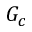Convert formula to latex. <formula><loc_0><loc_0><loc_500><loc_500>G _ { c }</formula> 